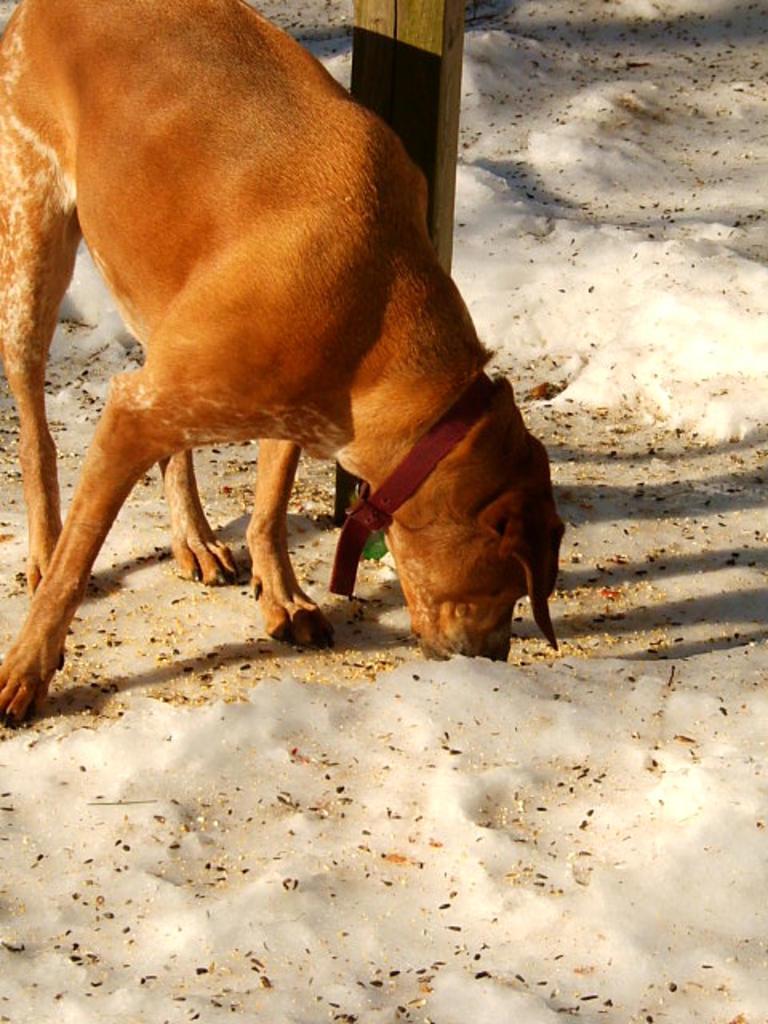How would you summarize this image in a sentence or two? In this image we can see a dog on the ground. We can also see a wooden pole. 